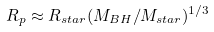<formula> <loc_0><loc_0><loc_500><loc_500>R _ { p } \approx R _ { s t a r } ( M _ { B H } / M _ { s t a r } ) ^ { 1 / 3 }</formula> 